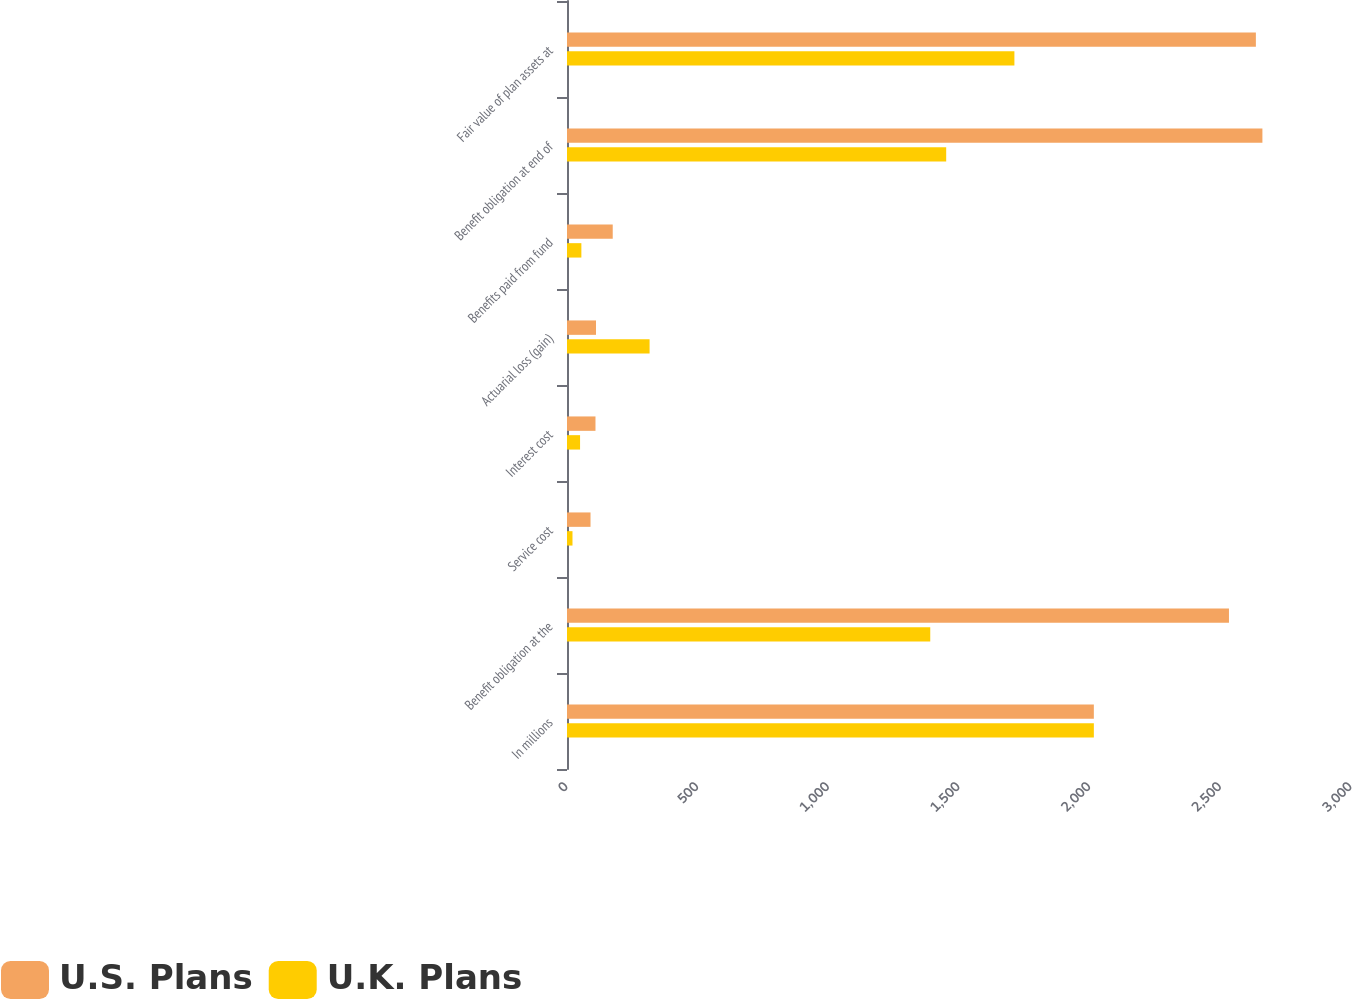Convert chart to OTSL. <chart><loc_0><loc_0><loc_500><loc_500><stacked_bar_chart><ecel><fcel>In millions<fcel>Benefit obligation at the<fcel>Service cost<fcel>Interest cost<fcel>Actuarial loss (gain)<fcel>Benefits paid from fund<fcel>Benefit obligation at end of<fcel>Fair value of plan assets at<nl><fcel>U.S. Plans<fcel>2016<fcel>2533<fcel>90<fcel>109<fcel>111<fcel>175<fcel>2661<fcel>2636<nl><fcel>U.K. Plans<fcel>2016<fcel>1390<fcel>21<fcel>50<fcel>316<fcel>55<fcel>1451<fcel>1712<nl></chart> 